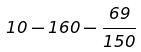Convert formula to latex. <formula><loc_0><loc_0><loc_500><loc_500>1 0 - 1 6 0 - \frac { 6 9 } { 1 5 0 }</formula> 